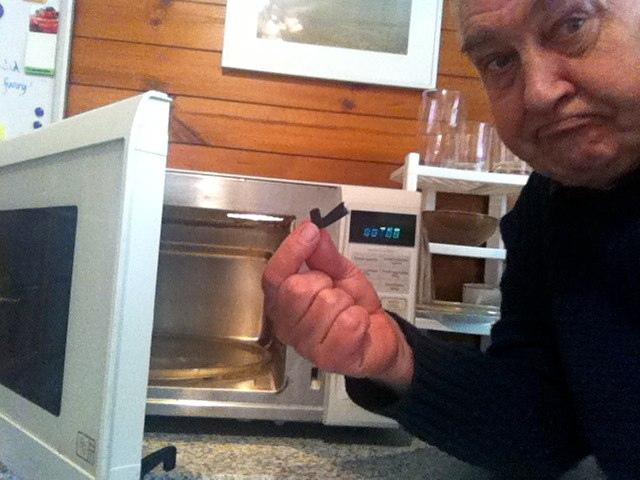What does the man hold? Please explain your reasoning. microwave part. The piece in the man's hand looks much like the black piece still on the door of the microwave. a microwave should have two of these pieces to hold the door closed while in operation. 